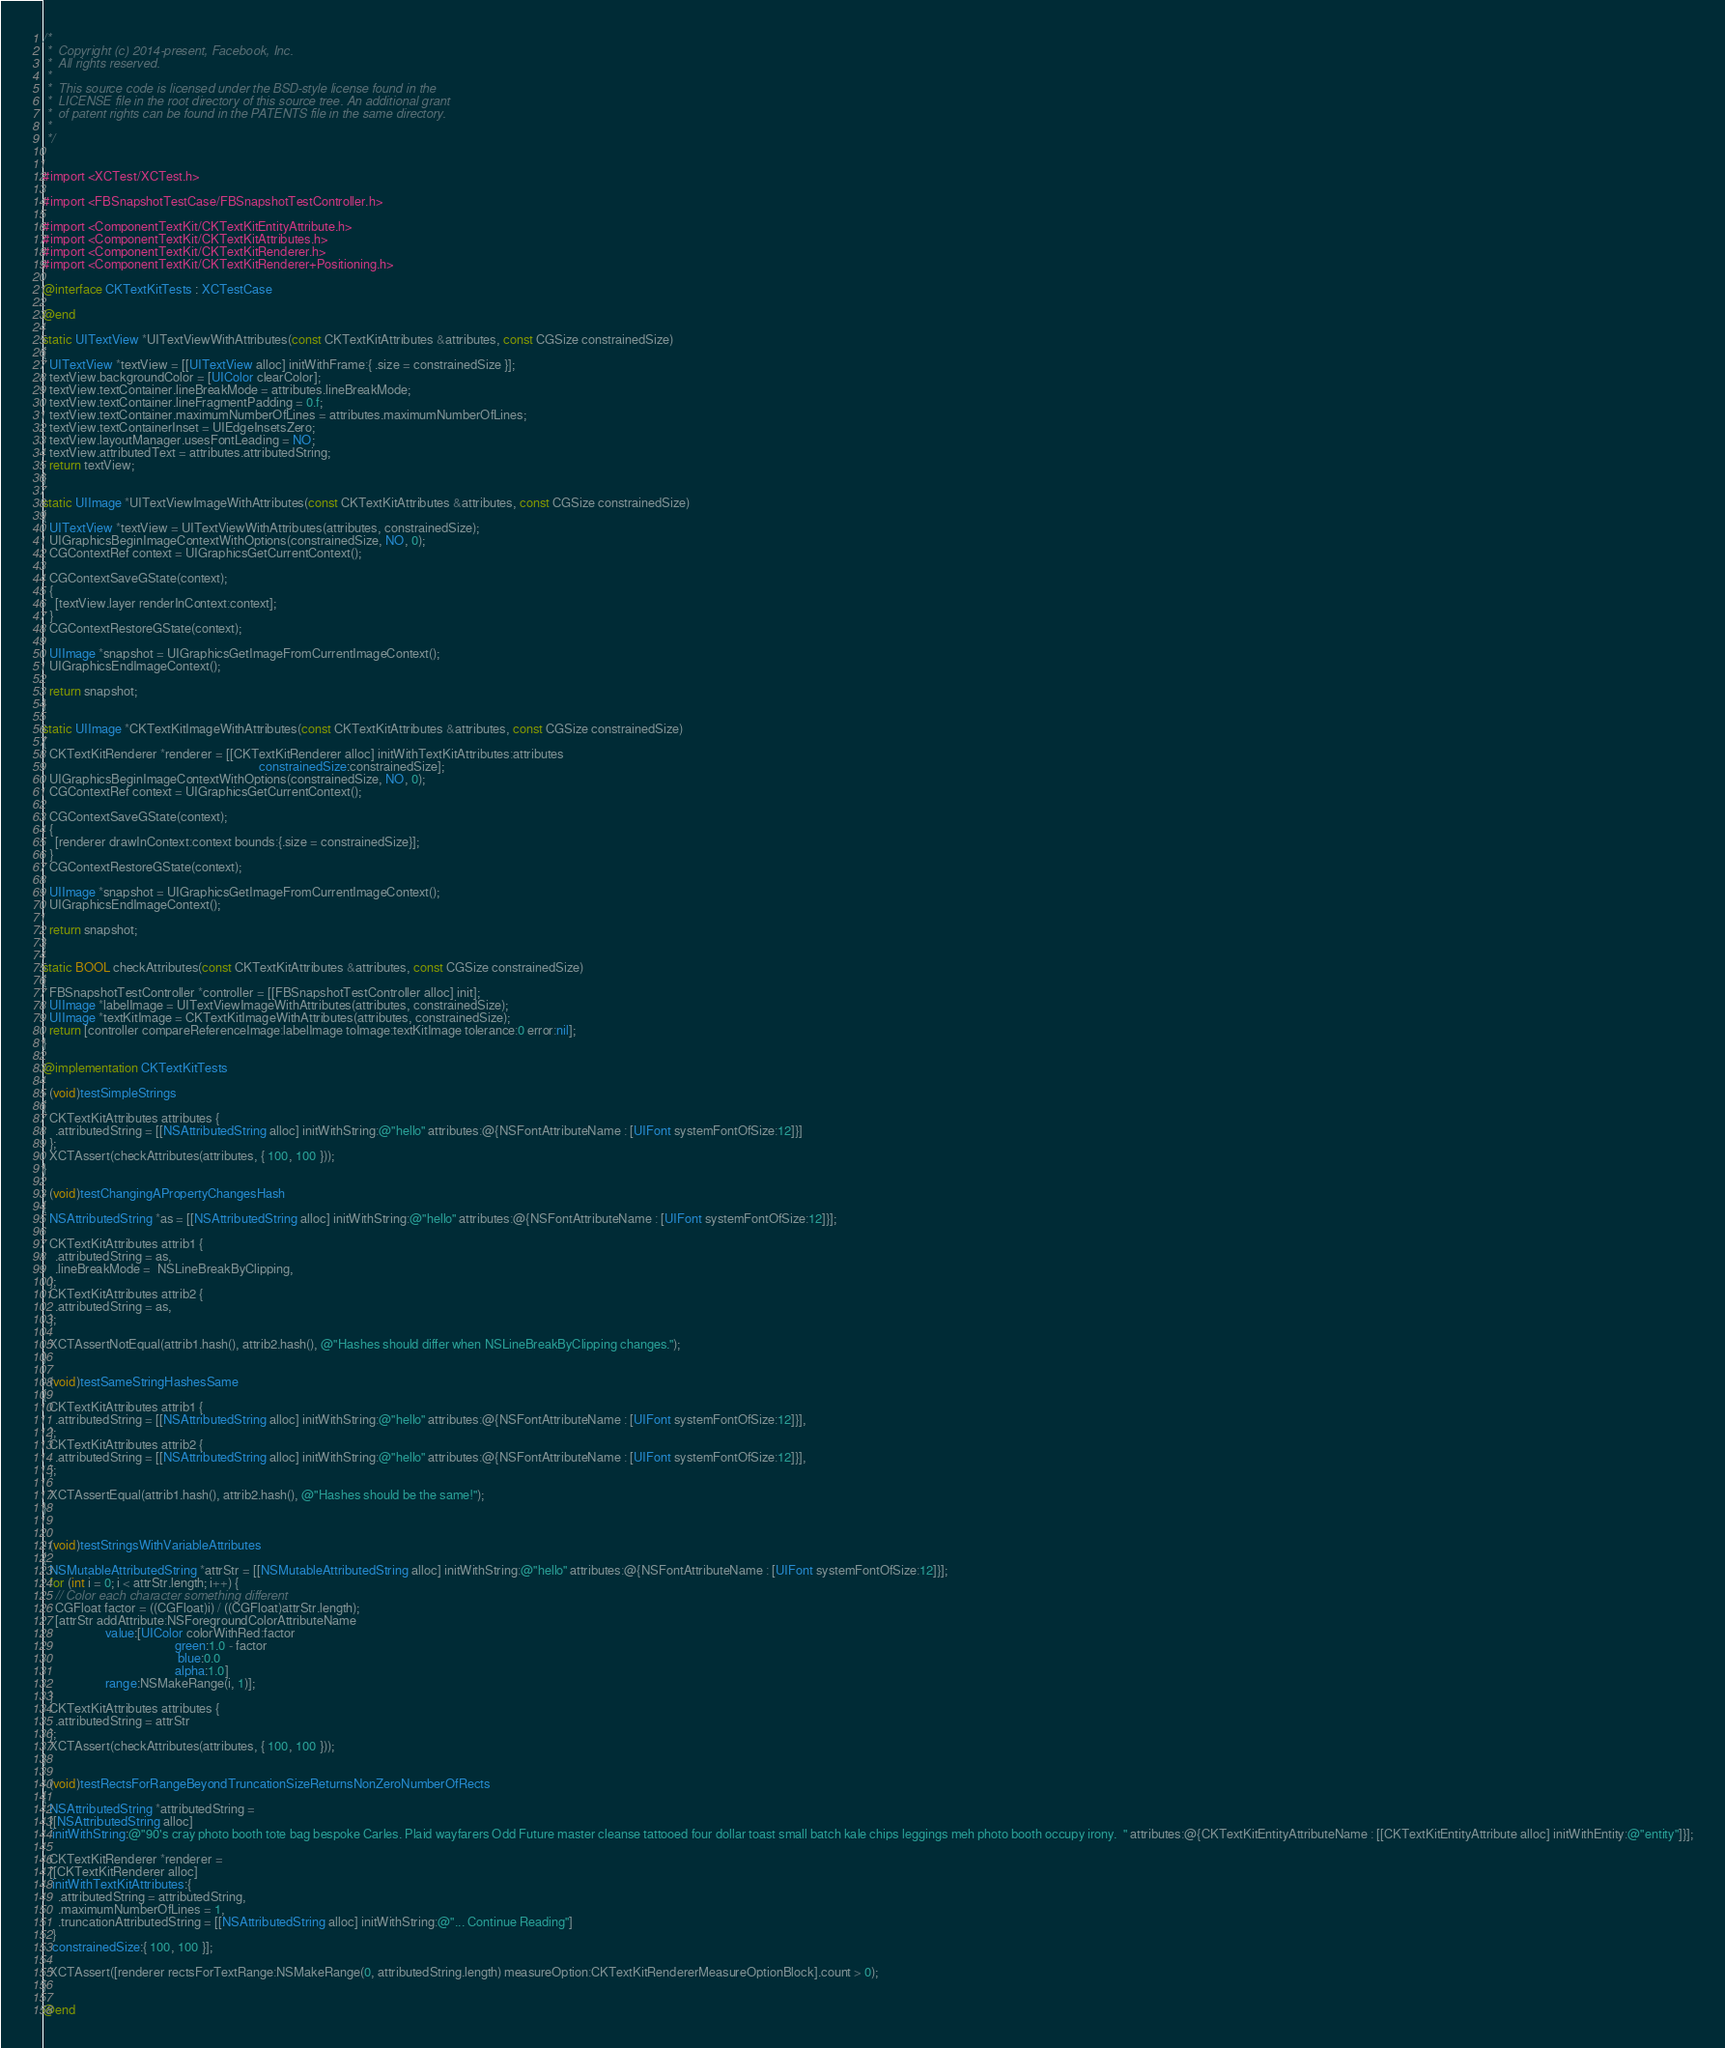Convert code to text. <code><loc_0><loc_0><loc_500><loc_500><_ObjectiveC_>/*
 *  Copyright (c) 2014-present, Facebook, Inc.
 *  All rights reserved.
 *
 *  This source code is licensed under the BSD-style license found in the
 *  LICENSE file in the root directory of this source tree. An additional grant
 *  of patent rights can be found in the PATENTS file in the same directory.
 *
 */


#import <XCTest/XCTest.h>

#import <FBSnapshotTestCase/FBSnapshotTestController.h>

#import <ComponentTextKit/CKTextKitEntityAttribute.h>
#import <ComponentTextKit/CKTextKitAttributes.h>
#import <ComponentTextKit/CKTextKitRenderer.h>
#import <ComponentTextKit/CKTextKitRenderer+Positioning.h>

@interface CKTextKitTests : XCTestCase

@end

static UITextView *UITextViewWithAttributes(const CKTextKitAttributes &attributes, const CGSize constrainedSize)
{
  UITextView *textView = [[UITextView alloc] initWithFrame:{ .size = constrainedSize }];
  textView.backgroundColor = [UIColor clearColor];
  textView.textContainer.lineBreakMode = attributes.lineBreakMode;
  textView.textContainer.lineFragmentPadding = 0.f;
  textView.textContainer.maximumNumberOfLines = attributes.maximumNumberOfLines;
  textView.textContainerInset = UIEdgeInsetsZero;
  textView.layoutManager.usesFontLeading = NO;
  textView.attributedText = attributes.attributedString;
  return textView;
}

static UIImage *UITextViewImageWithAttributes(const CKTextKitAttributes &attributes, const CGSize constrainedSize)
{
  UITextView *textView = UITextViewWithAttributes(attributes, constrainedSize);
  UIGraphicsBeginImageContextWithOptions(constrainedSize, NO, 0);
  CGContextRef context = UIGraphicsGetCurrentContext();

  CGContextSaveGState(context);
  {
    [textView.layer renderInContext:context];
  }
  CGContextRestoreGState(context);

  UIImage *snapshot = UIGraphicsGetImageFromCurrentImageContext();
  UIGraphicsEndImageContext();

  return snapshot;
}

static UIImage *CKTextKitImageWithAttributes(const CKTextKitAttributes &attributes, const CGSize constrainedSize)
{
  CKTextKitRenderer *renderer = [[CKTextKitRenderer alloc] initWithTextKitAttributes:attributes
                                                                     constrainedSize:constrainedSize];
  UIGraphicsBeginImageContextWithOptions(constrainedSize, NO, 0);
  CGContextRef context = UIGraphicsGetCurrentContext();

  CGContextSaveGState(context);
  {
    [renderer drawInContext:context bounds:{.size = constrainedSize}];
  }
  CGContextRestoreGState(context);

  UIImage *snapshot = UIGraphicsGetImageFromCurrentImageContext();
  UIGraphicsEndImageContext();

  return snapshot;
}

static BOOL checkAttributes(const CKTextKitAttributes &attributes, const CGSize constrainedSize)
{
  FBSnapshotTestController *controller = [[FBSnapshotTestController alloc] init];
  UIImage *labelImage = UITextViewImageWithAttributes(attributes, constrainedSize);
  UIImage *textKitImage = CKTextKitImageWithAttributes(attributes, constrainedSize);
  return [controller compareReferenceImage:labelImage toImage:textKitImage tolerance:0 error:nil];
}

@implementation CKTextKitTests

- (void)testSimpleStrings
{
  CKTextKitAttributes attributes {
    .attributedString = [[NSAttributedString alloc] initWithString:@"hello" attributes:@{NSFontAttributeName : [UIFont systemFontOfSize:12]}]
  };
  XCTAssert(checkAttributes(attributes, { 100, 100 }));
}

- (void)testChangingAPropertyChangesHash
{
  NSAttributedString *as = [[NSAttributedString alloc] initWithString:@"hello" attributes:@{NSFontAttributeName : [UIFont systemFontOfSize:12]}];

  CKTextKitAttributes attrib1 {
    .attributedString = as,
    .lineBreakMode =  NSLineBreakByClipping,
  };
  CKTextKitAttributes attrib2 {
    .attributedString = as,
  };

  XCTAssertNotEqual(attrib1.hash(), attrib2.hash(), @"Hashes should differ when NSLineBreakByClipping changes.");
}

- (void)testSameStringHashesSame
{
  CKTextKitAttributes attrib1 {
    .attributedString = [[NSAttributedString alloc] initWithString:@"hello" attributes:@{NSFontAttributeName : [UIFont systemFontOfSize:12]}],
  };
  CKTextKitAttributes attrib2 {
    .attributedString = [[NSAttributedString alloc] initWithString:@"hello" attributes:@{NSFontAttributeName : [UIFont systemFontOfSize:12]}],
  };

  XCTAssertEqual(attrib1.hash(), attrib2.hash(), @"Hashes should be the same!");
}


- (void)testStringsWithVariableAttributes
{
  NSMutableAttributedString *attrStr = [[NSMutableAttributedString alloc] initWithString:@"hello" attributes:@{NSFontAttributeName : [UIFont systemFontOfSize:12]}];
  for (int i = 0; i < attrStr.length; i++) {
    // Color each character something different
    CGFloat factor = ((CGFloat)i) / ((CGFloat)attrStr.length);
    [attrStr addAttribute:NSForegroundColorAttributeName
                    value:[UIColor colorWithRed:factor
                                          green:1.0 - factor
                                           blue:0.0
                                          alpha:1.0]
                    range:NSMakeRange(i, 1)];
  }
  CKTextKitAttributes attributes {
    .attributedString = attrStr
  };
  XCTAssert(checkAttributes(attributes, { 100, 100 }));
}

- (void)testRectsForRangeBeyondTruncationSizeReturnsNonZeroNumberOfRects
{
  NSAttributedString *attributedString =
  [[NSAttributedString alloc]
   initWithString:@"90's cray photo booth tote bag bespoke Carles. Plaid wayfarers Odd Future master cleanse tattooed four dollar toast small batch kale chips leggings meh photo booth occupy irony.  " attributes:@{CKTextKitEntityAttributeName : [[CKTextKitEntityAttribute alloc] initWithEntity:@"entity"]}];

  CKTextKitRenderer *renderer =
  [[CKTextKitRenderer alloc]
   initWithTextKitAttributes:{
     .attributedString = attributedString,
     .maximumNumberOfLines = 1,
     .truncationAttributedString = [[NSAttributedString alloc] initWithString:@"... Continue Reading"]
   }
   constrainedSize:{ 100, 100 }];

  XCTAssert([renderer rectsForTextRange:NSMakeRange(0, attributedString.length) measureOption:CKTextKitRendererMeasureOptionBlock].count > 0);
}

@end
</code> 